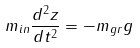Convert formula to latex. <formula><loc_0><loc_0><loc_500><loc_500>m _ { i n } \frac { d ^ { 2 } z } { d t ^ { 2 } } = - m _ { g r } g</formula> 